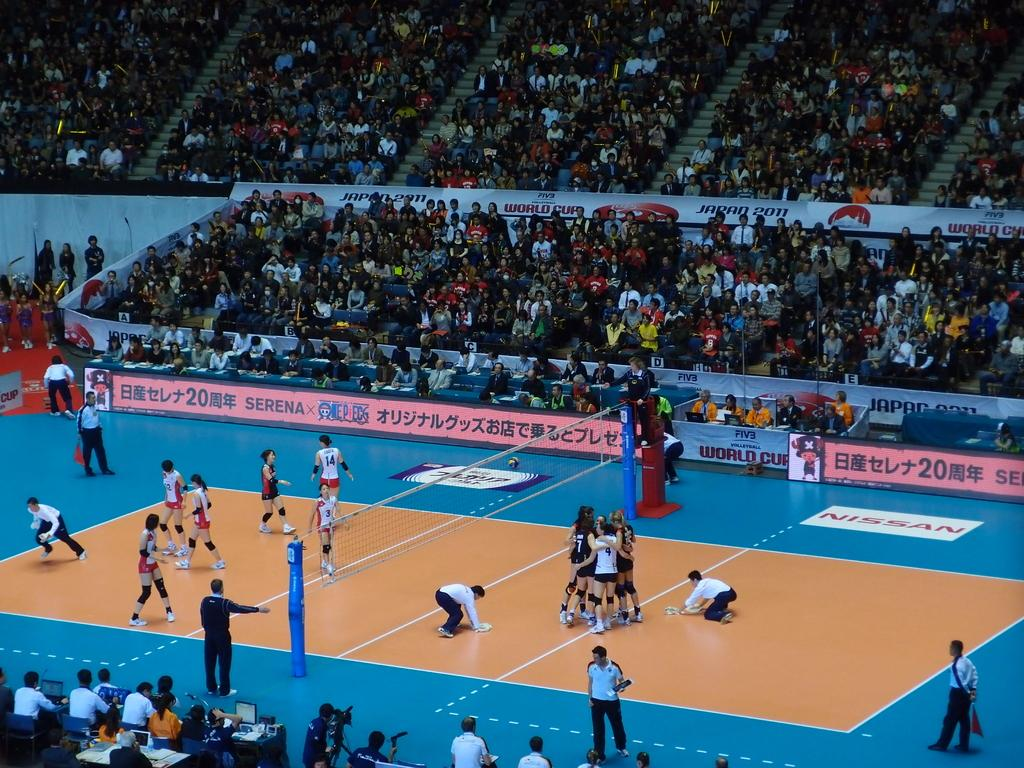Provide a one-sentence caption for the provided image. A woman's volley ball game sponsored by Nissan. 